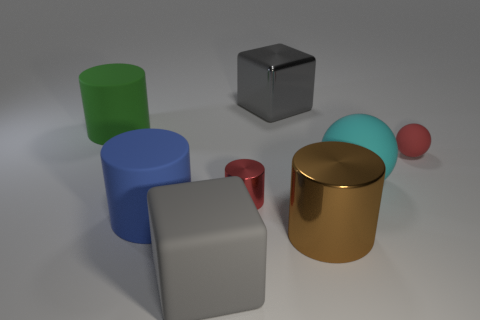Add 1 cyan rubber balls. How many objects exist? 9 Subtract all big blue matte cylinders. How many cylinders are left? 3 Subtract 1 cylinders. How many cylinders are left? 3 Subtract all red balls. How many balls are left? 1 Subtract all cubes. How many objects are left? 6 Add 4 spheres. How many spheres are left? 6 Add 6 red balls. How many red balls exist? 7 Subtract 1 cyan balls. How many objects are left? 7 Subtract all blue cylinders. Subtract all purple blocks. How many cylinders are left? 3 Subtract all brown matte balls. Subtract all red rubber objects. How many objects are left? 7 